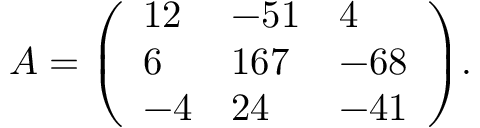<formula> <loc_0><loc_0><loc_500><loc_500>A = { \left ( \begin{array} { l l l } { 1 2 } & { - 5 1 } & { 4 } \\ { 6 } & { 1 6 7 } & { - 6 8 } \\ { - 4 } & { 2 4 } & { - 4 1 } \end{array} \right ) } .</formula> 